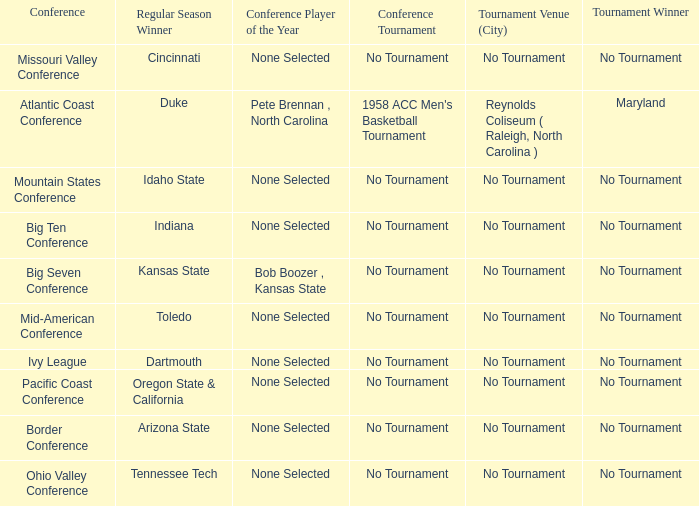Who won the regular season when Maryland won the tournament? Duke. 